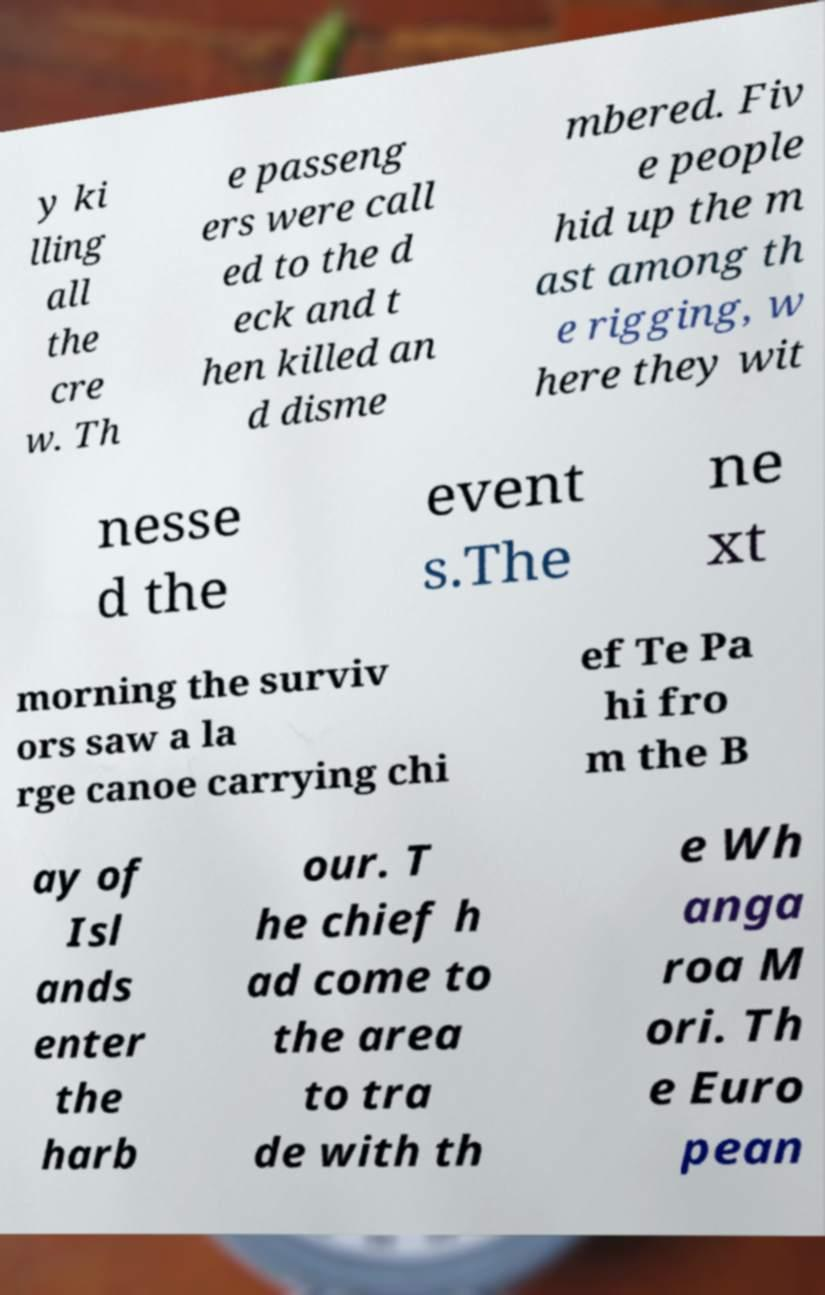For documentation purposes, I need the text within this image transcribed. Could you provide that? y ki lling all the cre w. Th e passeng ers were call ed to the d eck and t hen killed an d disme mbered. Fiv e people hid up the m ast among th e rigging, w here they wit nesse d the event s.The ne xt morning the surviv ors saw a la rge canoe carrying chi ef Te Pa hi fro m the B ay of Isl ands enter the harb our. T he chief h ad come to the area to tra de with th e Wh anga roa M ori. Th e Euro pean 